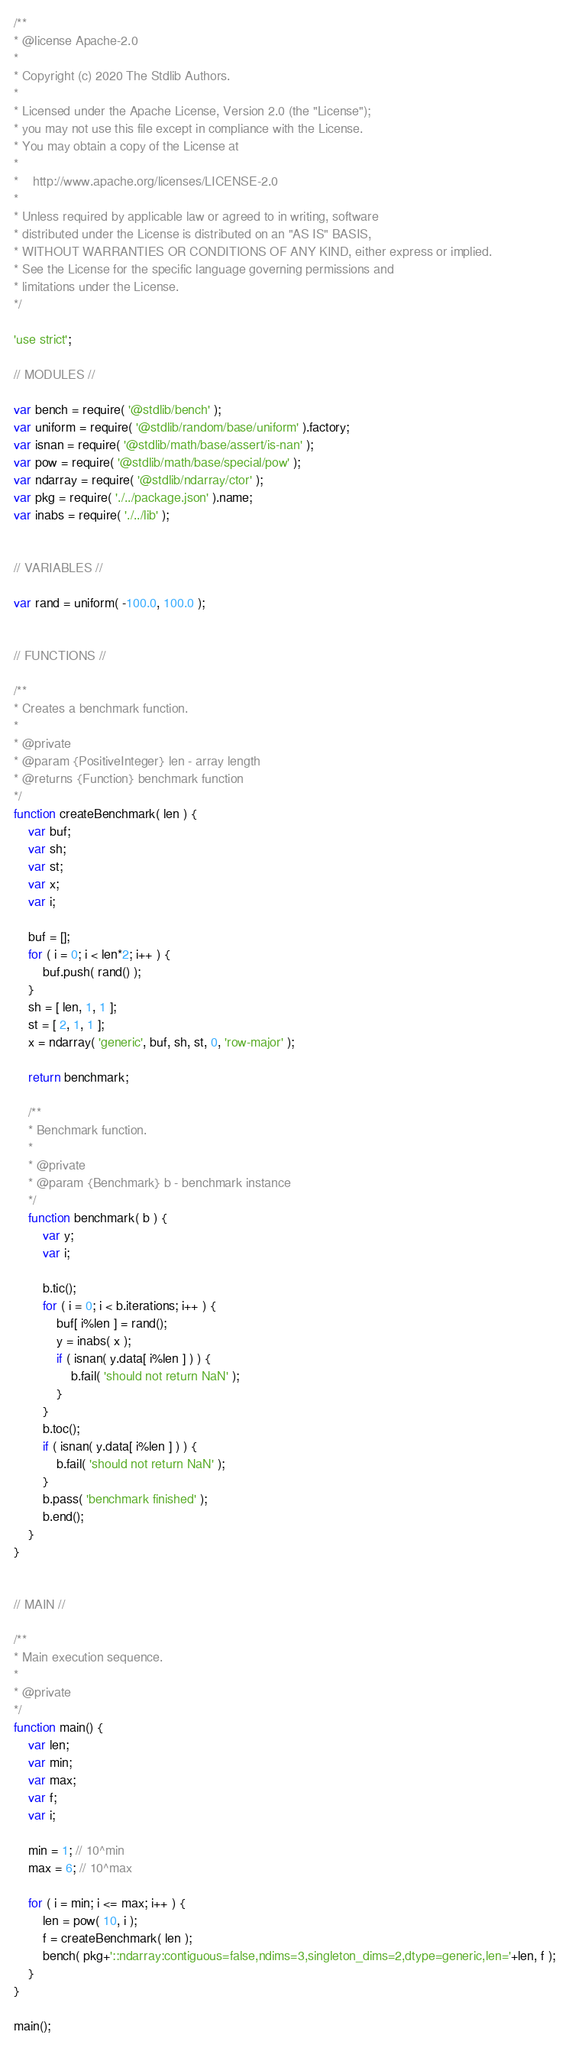<code> <loc_0><loc_0><loc_500><loc_500><_JavaScript_>/**
* @license Apache-2.0
*
* Copyright (c) 2020 The Stdlib Authors.
*
* Licensed under the Apache License, Version 2.0 (the "License");
* you may not use this file except in compliance with the License.
* You may obtain a copy of the License at
*
*    http://www.apache.org/licenses/LICENSE-2.0
*
* Unless required by applicable law or agreed to in writing, software
* distributed under the License is distributed on an "AS IS" BASIS,
* WITHOUT WARRANTIES OR CONDITIONS OF ANY KIND, either express or implied.
* See the License for the specific language governing permissions and
* limitations under the License.
*/

'use strict';

// MODULES //

var bench = require( '@stdlib/bench' );
var uniform = require( '@stdlib/random/base/uniform' ).factory;
var isnan = require( '@stdlib/math/base/assert/is-nan' );
var pow = require( '@stdlib/math/base/special/pow' );
var ndarray = require( '@stdlib/ndarray/ctor' );
var pkg = require( './../package.json' ).name;
var inabs = require( './../lib' );


// VARIABLES //

var rand = uniform( -100.0, 100.0 );


// FUNCTIONS //

/**
* Creates a benchmark function.
*
* @private
* @param {PositiveInteger} len - array length
* @returns {Function} benchmark function
*/
function createBenchmark( len ) {
	var buf;
	var sh;
	var st;
	var x;
	var i;

	buf = [];
	for ( i = 0; i < len*2; i++ ) {
		buf.push( rand() );
	}
	sh = [ len, 1, 1 ];
	st = [ 2, 1, 1 ];
	x = ndarray( 'generic', buf, sh, st, 0, 'row-major' );

	return benchmark;

	/**
	* Benchmark function.
	*
	* @private
	* @param {Benchmark} b - benchmark instance
	*/
	function benchmark( b ) {
		var y;
		var i;

		b.tic();
		for ( i = 0; i < b.iterations; i++ ) {
			buf[ i%len ] = rand();
			y = inabs( x );
			if ( isnan( y.data[ i%len ] ) ) {
				b.fail( 'should not return NaN' );
			}
		}
		b.toc();
		if ( isnan( y.data[ i%len ] ) ) {
			b.fail( 'should not return NaN' );
		}
		b.pass( 'benchmark finished' );
		b.end();
	}
}


// MAIN //

/**
* Main execution sequence.
*
* @private
*/
function main() {
	var len;
	var min;
	var max;
	var f;
	var i;

	min = 1; // 10^min
	max = 6; // 10^max

	for ( i = min; i <= max; i++ ) {
		len = pow( 10, i );
		f = createBenchmark( len );
		bench( pkg+'::ndarray:contiguous=false,ndims=3,singleton_dims=2,dtype=generic,len='+len, f );
	}
}

main();
</code> 